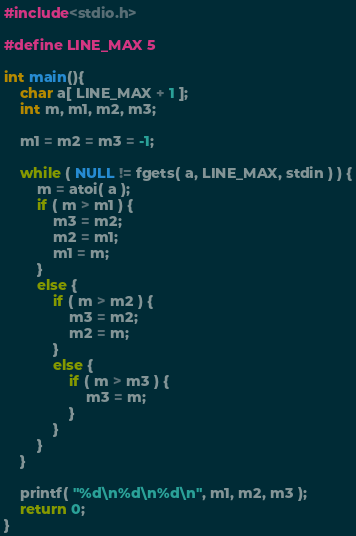<code> <loc_0><loc_0><loc_500><loc_500><_C_>#include<stdio.h>

#define LINE_MAX 5

int main(){
    char a[ LINE_MAX + 1 ];
    int m, m1, m2, m3;

    m1 = m2 = m3 = -1;

    while ( NULL != fgets( a, LINE_MAX, stdin ) ) {
        m = atoi( a );
        if ( m > m1 ) {
            m3 = m2;
            m2 = m1;
            m1 = m;
        }
        else {
            if ( m > m2 ) {
                m3 = m2;
                m2 = m;
            }
            else {
                if ( m > m3 ) {
                    m3 = m;
                }
            }
        }
    }

    printf( "%d\n%d\n%d\n", m1, m2, m3 );
    return 0;
}</code> 